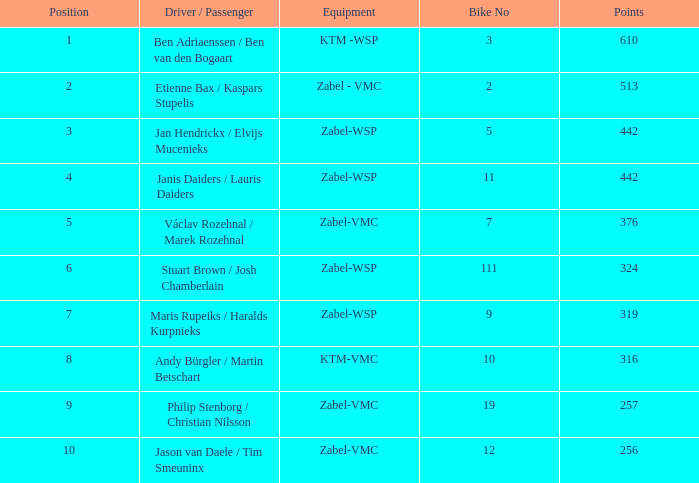What is the topmost position having a points of 257, and a bike no greater than or equal to 19? None. 